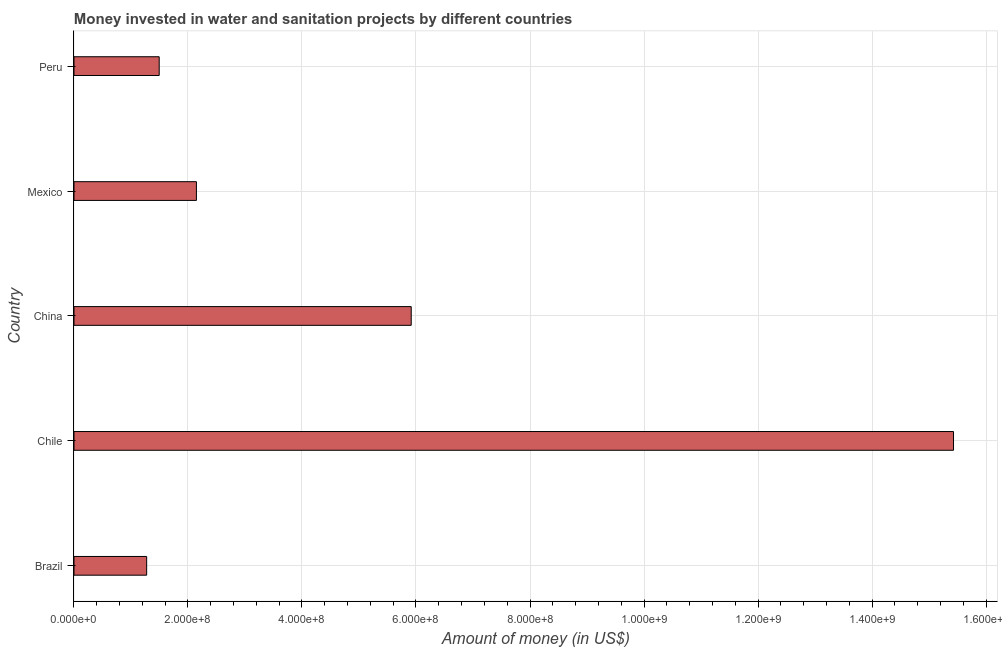Does the graph contain any zero values?
Your response must be concise. No. What is the title of the graph?
Provide a succinct answer. Money invested in water and sanitation projects by different countries. What is the label or title of the X-axis?
Make the answer very short. Amount of money (in US$). What is the label or title of the Y-axis?
Provide a short and direct response. Country. What is the investment in China?
Your answer should be compact. 5.92e+08. Across all countries, what is the maximum investment?
Ensure brevity in your answer.  1.54e+09. Across all countries, what is the minimum investment?
Give a very brief answer. 1.28e+08. In which country was the investment maximum?
Your answer should be compact. Chile. In which country was the investment minimum?
Provide a succinct answer. Brazil. What is the sum of the investment?
Give a very brief answer. 2.63e+09. What is the difference between the investment in China and Peru?
Offer a terse response. 4.42e+08. What is the average investment per country?
Your answer should be compact. 5.25e+08. What is the median investment?
Offer a terse response. 2.15e+08. What is the ratio of the investment in Brazil to that in Mexico?
Ensure brevity in your answer.  0.59. Is the difference between the investment in Chile and Mexico greater than the difference between any two countries?
Offer a terse response. No. What is the difference between the highest and the second highest investment?
Your answer should be compact. 9.51e+08. What is the difference between the highest and the lowest investment?
Your response must be concise. 1.42e+09. In how many countries, is the investment greater than the average investment taken over all countries?
Give a very brief answer. 2. How many bars are there?
Your answer should be very brief. 5. How many countries are there in the graph?
Your answer should be very brief. 5. What is the difference between two consecutive major ticks on the X-axis?
Ensure brevity in your answer.  2.00e+08. What is the Amount of money (in US$) in Brazil?
Your answer should be very brief. 1.28e+08. What is the Amount of money (in US$) of Chile?
Keep it short and to the point. 1.54e+09. What is the Amount of money (in US$) of China?
Offer a very short reply. 5.92e+08. What is the Amount of money (in US$) in Mexico?
Your answer should be compact. 2.15e+08. What is the Amount of money (in US$) of Peru?
Offer a very short reply. 1.50e+08. What is the difference between the Amount of money (in US$) in Brazil and Chile?
Give a very brief answer. -1.42e+09. What is the difference between the Amount of money (in US$) in Brazil and China?
Offer a very short reply. -4.64e+08. What is the difference between the Amount of money (in US$) in Brazil and Mexico?
Your response must be concise. -8.73e+07. What is the difference between the Amount of money (in US$) in Brazil and Peru?
Give a very brief answer. -2.20e+07. What is the difference between the Amount of money (in US$) in Chile and China?
Keep it short and to the point. 9.51e+08. What is the difference between the Amount of money (in US$) in Chile and Mexico?
Your answer should be very brief. 1.33e+09. What is the difference between the Amount of money (in US$) in Chile and Peru?
Your answer should be compact. 1.39e+09. What is the difference between the Amount of money (in US$) in China and Mexico?
Give a very brief answer. 3.77e+08. What is the difference between the Amount of money (in US$) in China and Peru?
Ensure brevity in your answer.  4.42e+08. What is the difference between the Amount of money (in US$) in Mexico and Peru?
Offer a very short reply. 6.53e+07. What is the ratio of the Amount of money (in US$) in Brazil to that in Chile?
Make the answer very short. 0.08. What is the ratio of the Amount of money (in US$) in Brazil to that in China?
Your answer should be compact. 0.22. What is the ratio of the Amount of money (in US$) in Brazil to that in Mexico?
Ensure brevity in your answer.  0.59. What is the ratio of the Amount of money (in US$) in Brazil to that in Peru?
Your answer should be very brief. 0.85. What is the ratio of the Amount of money (in US$) in Chile to that in China?
Offer a very short reply. 2.61. What is the ratio of the Amount of money (in US$) in Chile to that in Mexico?
Your answer should be very brief. 7.18. What is the ratio of the Amount of money (in US$) in Chile to that in Peru?
Offer a terse response. 10.32. What is the ratio of the Amount of money (in US$) in China to that in Mexico?
Offer a very short reply. 2.75. What is the ratio of the Amount of money (in US$) in China to that in Peru?
Make the answer very short. 3.96. What is the ratio of the Amount of money (in US$) in Mexico to that in Peru?
Your answer should be compact. 1.44. 